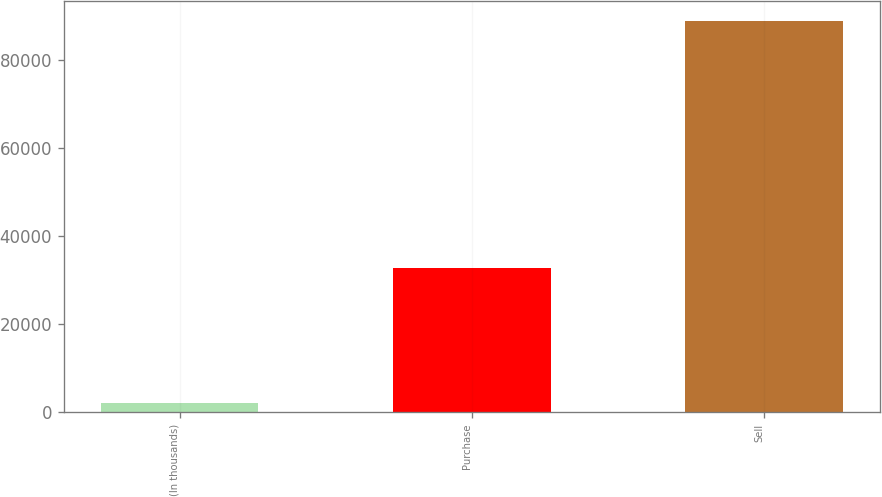Convert chart. <chart><loc_0><loc_0><loc_500><loc_500><bar_chart><fcel>(In thousands)<fcel>Purchase<fcel>Sell<nl><fcel>2015<fcel>32775<fcel>88800<nl></chart> 